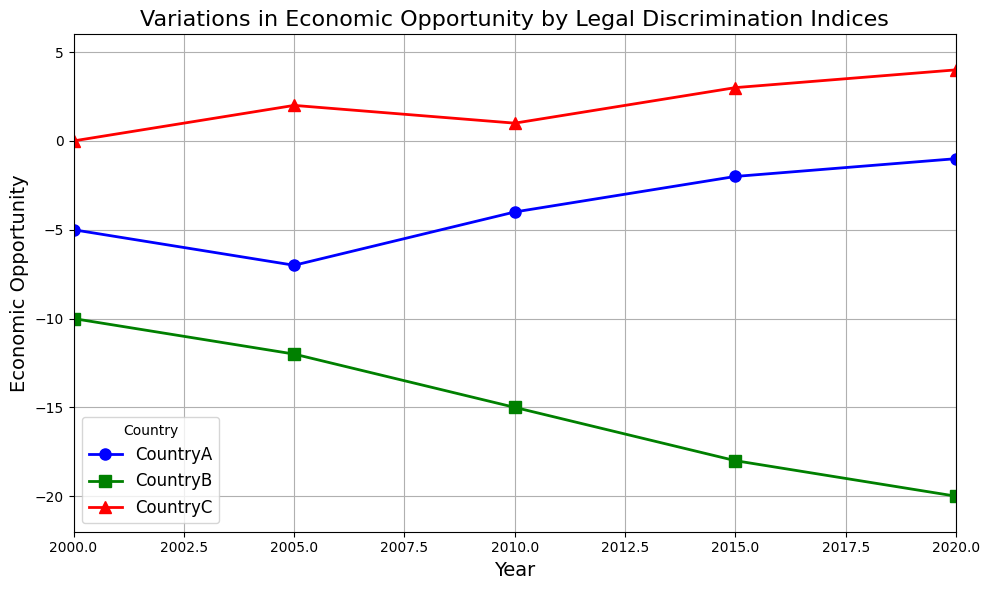What trend do you observe in CountryA's Economic Opportunity from 2000 to 2020? We observe the value of Economic Opportunity for CountryA at different time points. In 2000, it is -5. By 2005, it decreases to -7 but then shows an increasing trend: -4 in 2010, -2 in 2015, and -1 in 2020. Thus, it overall improves from -5 to -1 over the years.
Answer: The Economic Opportunity for CountryA improves from -5 to -1 How does CountryB's Economic Opportunity in 2020 compare to that in 2000? By comparing the Economic Opportunity values, we see that CountryB's value in 2000 is -10 and in 2020 is -20. Subtracting these, we find a decrease of 10.
Answer: It decreased by 10 Which country consistently shows a positive Economic Opportunity from 2000 to 2020? We look at each country's Economic Opportunity values over the years. CountryA and CountryB consistently have negative values, while CountryC has positive values starting from 2005 onwards. Hence, CountryC consistently shows positive Economic Opportunity.
Answer: CountryC What was the combined Economic Opportunity of all three countries in 2015? We sum up the Economic Opportunity for each country in 2015: CountryA (-2), CountryB (-18), and CountryC (3). Calculating, we get -2 + -18 + 3 = -17.
Answer: -17 Is there any year where all three countries show an improvement in Economic Opportunity compared to the previous recorded year? To find this, compare the Economic Opportunity of each country year by year. Comparing 2005 with 2000, CountryA decreases from -5 to -7, 2005 to 2010, CountryB decreases from -12 to -15. Comparatively in 2015 to 2010, CountryA improves from -4 to -2, and CountryC improves from 1 to 3. However, CountryB continues to worsen. Hence, no year achieves this collective improvement.
Answer: No Which year shows the highest Economic Opportunity for CountryC? We observe the Economic Opportunity values for CountryC: 0 in 2000, 2 in 2005, 1 in 2010, 3 in 2015, and 4 in 2020. The highest value among these is 4 in 2020.
Answer: 2020 Between which two consecutive years did CountryA see the greatest improvement in Economic Opportunity? By examining the difference in Economic Opportunity between consecutive years: from 2000 to 2005 (-5 to -7, decrease by 2), from 2005 to 2010 (-7 to -4, increase by 3), from 2010 to 2015 (-4 to -2, increase by 2), and from 2015 to 2020 (-2 to -1, increase by 1). The greatest improvement is from 2005 to 2010 by 3.
Answer: 2005 to 2010 